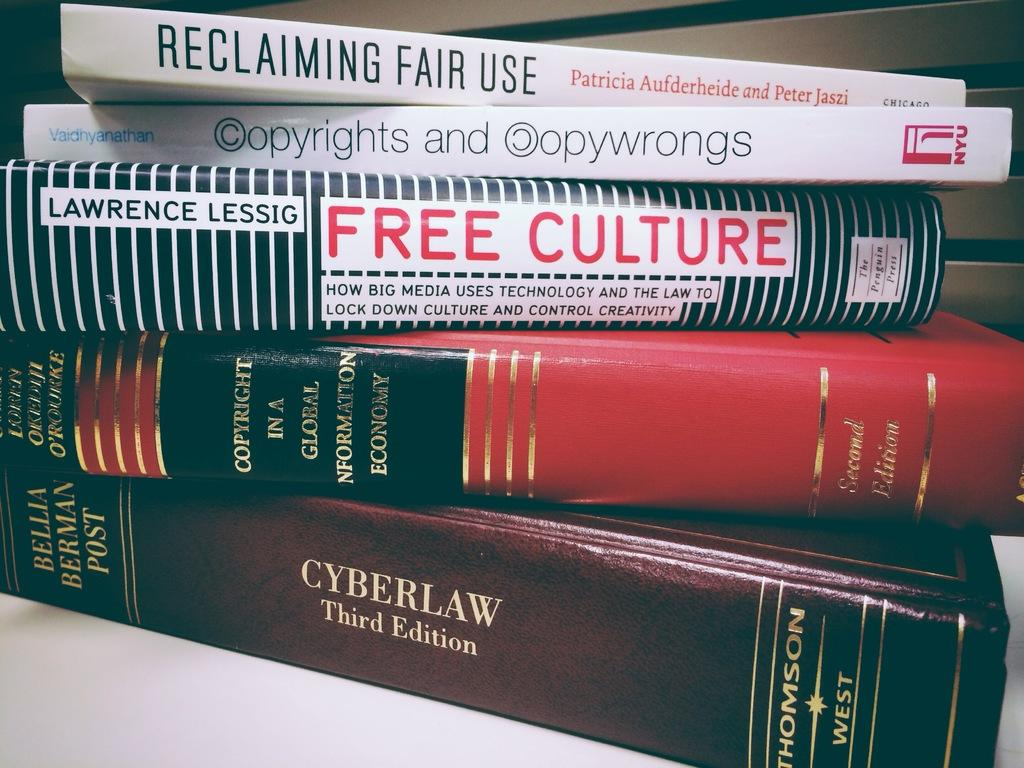<image>
Offer a succinct explanation of the picture presented. A stack of books including Free Culture by Lawrence Lessig. 